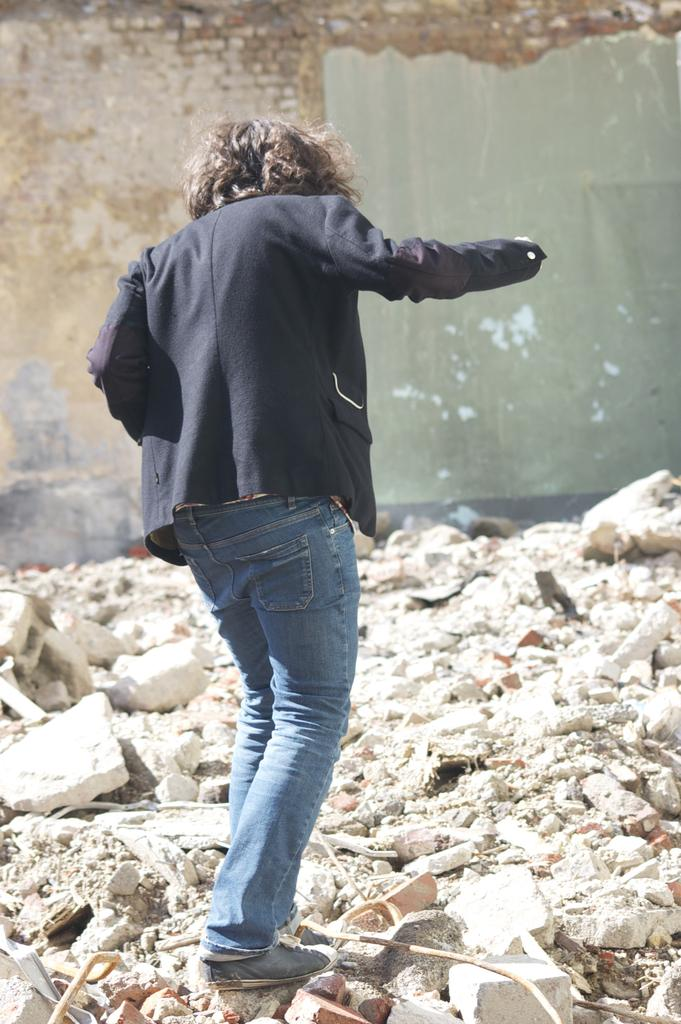Who is present in the image? There is a person in the image. What is the person wearing? The person is wearing a black suit. What is the person doing in the image? The person is walking on stones. What can be seen in the background of the image? There is a brick wall in the background of the image. What does the caption say about the person's grandfather in the image? There is no caption present in the image, and therefore no information about the person's grandfather can be determined. 